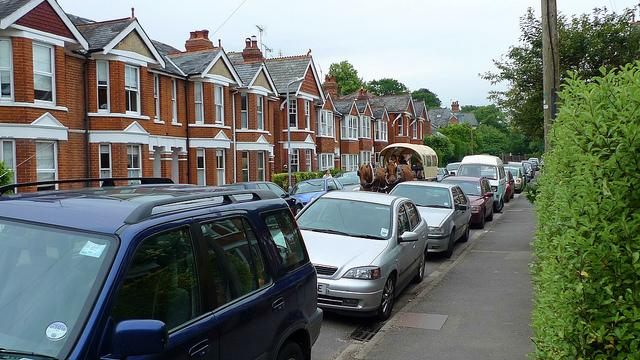Which conveyance pictured here uses less gas? Please explain your reasoning. buggy. The buggy in the middle of the road uses less gas than all of the cars parked on the street. 